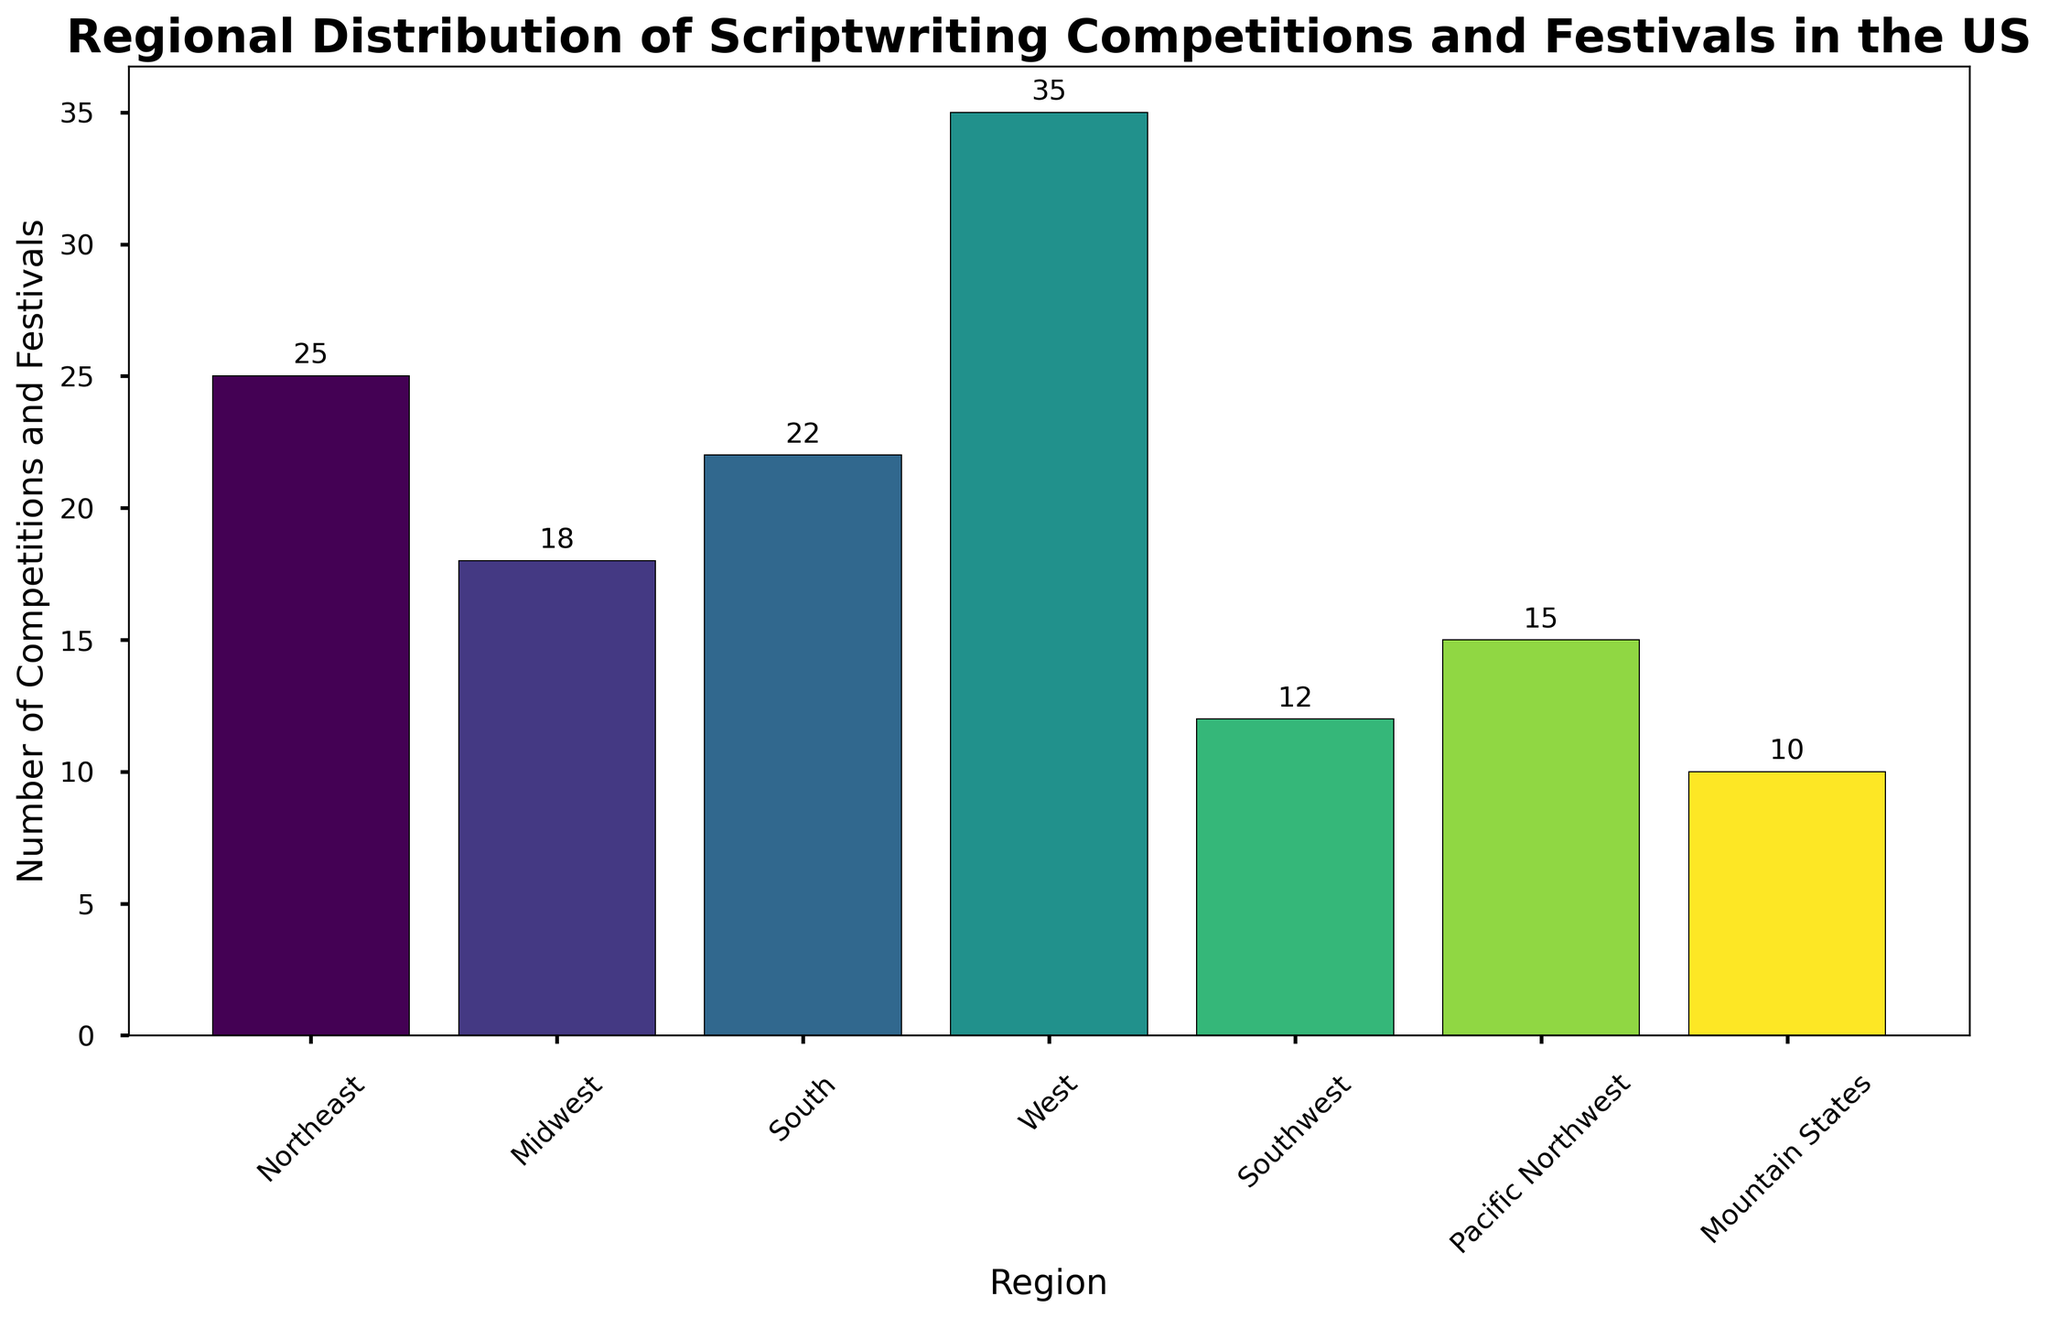What's the region with the most scriptwriting competitions and festivals? To determine the region with the highest number of scriptwriting competitions and festivals, look at the heights of the bars. The tallest bar represents the West region with 35 competitions and festivals.
Answer: West Which region has more scriptwriting competitions and festivals, the South or the Northeast? Compare the heights of the bars for the South and Northeast regions. The South region has 22 competitions and festivals, whereas the Northeast has 25. Therefore, the Northeast has more.
Answer: Northeast What's the total number of scriptwriting competitions and festivals in the Mountain States, Pacific Northwest, and Southwest combined? Sum the values for the Mountain States (10), Pacific Northwest (15), and Southwest (12) regions. The total is 10 + 15 + 12 = 37.
Answer: 37 How many regions have fewer than 20 scriptwriting competitions and festivals? Identify the bars with heights less than 20. The regions are Midwest (18), Southwest (12), Pacific Northwest (15), and Mountain States (10), which totals to four regions.
Answer: 4 What's the difference in the number of scriptwriting competitions and festivals between the West and the Midwest? Subtract the number of scriptwriting competitions and festivals in the Midwest (18) from the number in the West (35). The difference is 35 - 18 = 17.
Answer: 17 Which region falls in the middle in terms of the number of scriptwriting competitions and festivals? Arrange the regions by the number of competitions and festivals: Mountain States (10), Southwest (12), Pacific Northwest (15), Midwest (18), South (22), Northeast (25), West (35). The Midwest, with 18 competitions and festivals, is in the middle.
Answer: Midwest Approximately what percentage of total scriptwriting competitions and festivals does the West region represent? Calculate the total number of competitions and festivals across all regions: 25 + 18 + 22 + 35 + 12 + 15 + 10 = 137. The West has 35 competitions and festivals, so the percentage is (35/137) * 100 ≈ 25.5%.
Answer: 25.5% Which regions have their number of scriptwriting competitions and festivals between 10 and 20, inclusive? Identify the bars with heights between 10 and 20. These regions are Midwest (18), Southwest (12), Pacific Northwest (15), and Mountain States (10).
Answer: Midwest, Southwest, Pacific Northwest, Mountain States If the Northeast and South regions were combined, would their total be higher or lower than the West? Sum the values for the Northeast (25) and South (22) regions. The combined total is 25 + 22 = 47, which is higher than the West's 35.
Answer: Higher 